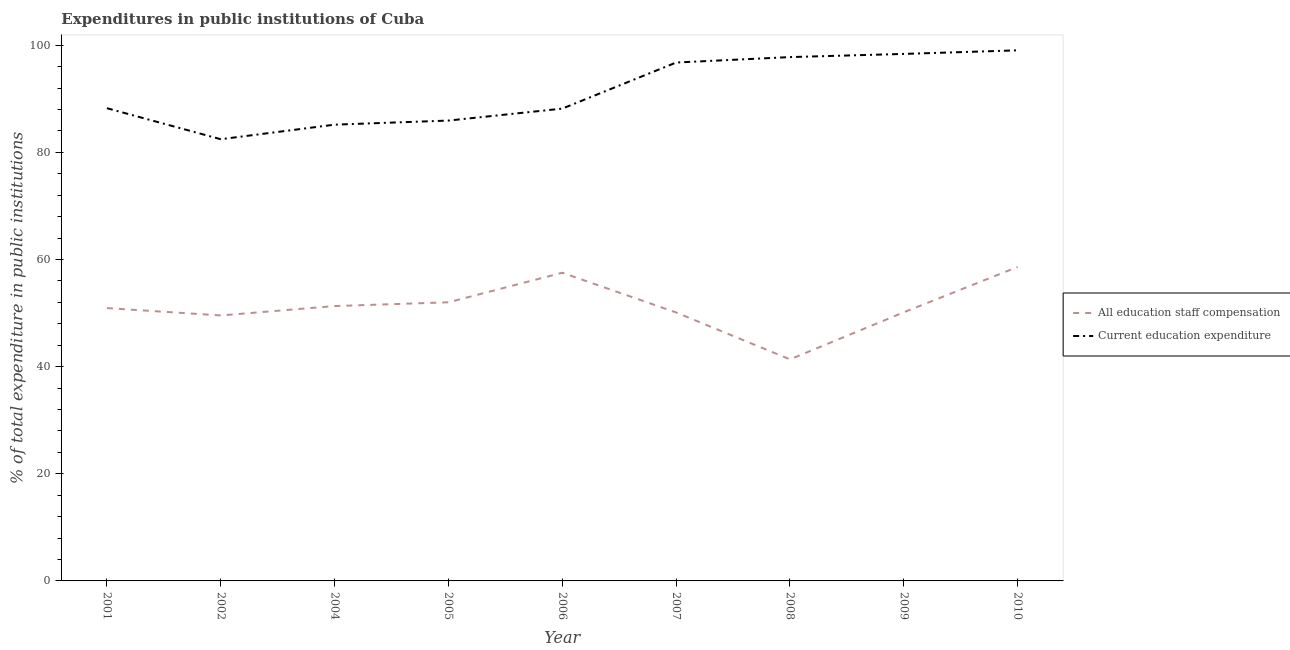Does the line corresponding to expenditure in staff compensation intersect with the line corresponding to expenditure in education?
Give a very brief answer. No. What is the expenditure in staff compensation in 2008?
Provide a short and direct response. 41.36. Across all years, what is the maximum expenditure in education?
Your response must be concise. 99.05. Across all years, what is the minimum expenditure in education?
Make the answer very short. 82.45. In which year was the expenditure in staff compensation maximum?
Ensure brevity in your answer.  2010. What is the total expenditure in education in the graph?
Provide a short and direct response. 821.94. What is the difference between the expenditure in staff compensation in 2007 and that in 2008?
Offer a very short reply. 8.76. What is the difference between the expenditure in staff compensation in 2007 and the expenditure in education in 2006?
Ensure brevity in your answer.  -38.05. What is the average expenditure in education per year?
Provide a short and direct response. 91.33. In the year 2002, what is the difference between the expenditure in staff compensation and expenditure in education?
Offer a terse response. -32.9. What is the ratio of the expenditure in staff compensation in 2001 to that in 2005?
Offer a terse response. 0.98. Is the difference between the expenditure in staff compensation in 2001 and 2010 greater than the difference between the expenditure in education in 2001 and 2010?
Offer a very short reply. Yes. What is the difference between the highest and the second highest expenditure in education?
Your answer should be very brief. 0.67. What is the difference between the highest and the lowest expenditure in education?
Provide a succinct answer. 16.59. In how many years, is the expenditure in staff compensation greater than the average expenditure in staff compensation taken over all years?
Offer a very short reply. 4. Is the sum of the expenditure in staff compensation in 2001 and 2006 greater than the maximum expenditure in education across all years?
Make the answer very short. Yes. Does the expenditure in education monotonically increase over the years?
Your answer should be very brief. No. Is the expenditure in staff compensation strictly greater than the expenditure in education over the years?
Offer a terse response. No. Is the expenditure in staff compensation strictly less than the expenditure in education over the years?
Your answer should be very brief. Yes. How many lines are there?
Provide a short and direct response. 2. Are the values on the major ticks of Y-axis written in scientific E-notation?
Provide a short and direct response. No. Does the graph contain any zero values?
Give a very brief answer. No. Does the graph contain grids?
Your response must be concise. No. Where does the legend appear in the graph?
Offer a very short reply. Center right. How many legend labels are there?
Offer a terse response. 2. What is the title of the graph?
Your answer should be compact. Expenditures in public institutions of Cuba. What is the label or title of the X-axis?
Offer a terse response. Year. What is the label or title of the Y-axis?
Your answer should be compact. % of total expenditure in public institutions. What is the % of total expenditure in public institutions of All education staff compensation in 2001?
Keep it short and to the point. 50.93. What is the % of total expenditure in public institutions in Current education expenditure in 2001?
Make the answer very short. 88.24. What is the % of total expenditure in public institutions in All education staff compensation in 2002?
Your answer should be very brief. 49.56. What is the % of total expenditure in public institutions in Current education expenditure in 2002?
Offer a very short reply. 82.45. What is the % of total expenditure in public institutions of All education staff compensation in 2004?
Provide a succinct answer. 51.31. What is the % of total expenditure in public institutions of Current education expenditure in 2004?
Provide a short and direct response. 85.17. What is the % of total expenditure in public institutions in All education staff compensation in 2005?
Keep it short and to the point. 52.01. What is the % of total expenditure in public institutions of Current education expenditure in 2005?
Your answer should be compact. 85.94. What is the % of total expenditure in public institutions in All education staff compensation in 2006?
Your answer should be very brief. 57.53. What is the % of total expenditure in public institutions of Current education expenditure in 2006?
Your answer should be very brief. 88.17. What is the % of total expenditure in public institutions of All education staff compensation in 2007?
Your answer should be compact. 50.11. What is the % of total expenditure in public institutions of Current education expenditure in 2007?
Ensure brevity in your answer.  96.77. What is the % of total expenditure in public institutions in All education staff compensation in 2008?
Provide a succinct answer. 41.36. What is the % of total expenditure in public institutions in Current education expenditure in 2008?
Your response must be concise. 97.78. What is the % of total expenditure in public institutions of All education staff compensation in 2009?
Offer a very short reply. 50.14. What is the % of total expenditure in public institutions of Current education expenditure in 2009?
Provide a succinct answer. 98.38. What is the % of total expenditure in public institutions of All education staff compensation in 2010?
Your response must be concise. 58.61. What is the % of total expenditure in public institutions of Current education expenditure in 2010?
Offer a terse response. 99.05. Across all years, what is the maximum % of total expenditure in public institutions in All education staff compensation?
Keep it short and to the point. 58.61. Across all years, what is the maximum % of total expenditure in public institutions in Current education expenditure?
Your answer should be compact. 99.05. Across all years, what is the minimum % of total expenditure in public institutions of All education staff compensation?
Make the answer very short. 41.36. Across all years, what is the minimum % of total expenditure in public institutions in Current education expenditure?
Offer a terse response. 82.45. What is the total % of total expenditure in public institutions of All education staff compensation in the graph?
Your answer should be very brief. 461.56. What is the total % of total expenditure in public institutions in Current education expenditure in the graph?
Your answer should be compact. 821.94. What is the difference between the % of total expenditure in public institutions in All education staff compensation in 2001 and that in 2002?
Offer a terse response. 1.37. What is the difference between the % of total expenditure in public institutions of Current education expenditure in 2001 and that in 2002?
Provide a short and direct response. 5.79. What is the difference between the % of total expenditure in public institutions in All education staff compensation in 2001 and that in 2004?
Your response must be concise. -0.38. What is the difference between the % of total expenditure in public institutions of Current education expenditure in 2001 and that in 2004?
Your answer should be compact. 3.07. What is the difference between the % of total expenditure in public institutions of All education staff compensation in 2001 and that in 2005?
Offer a very short reply. -1.08. What is the difference between the % of total expenditure in public institutions in Current education expenditure in 2001 and that in 2005?
Your answer should be compact. 2.31. What is the difference between the % of total expenditure in public institutions in All education staff compensation in 2001 and that in 2006?
Offer a very short reply. -6.6. What is the difference between the % of total expenditure in public institutions of Current education expenditure in 2001 and that in 2006?
Your answer should be very brief. 0.08. What is the difference between the % of total expenditure in public institutions of All education staff compensation in 2001 and that in 2007?
Offer a very short reply. 0.82. What is the difference between the % of total expenditure in public institutions of Current education expenditure in 2001 and that in 2007?
Your answer should be very brief. -8.53. What is the difference between the % of total expenditure in public institutions in All education staff compensation in 2001 and that in 2008?
Keep it short and to the point. 9.57. What is the difference between the % of total expenditure in public institutions in Current education expenditure in 2001 and that in 2008?
Give a very brief answer. -9.54. What is the difference between the % of total expenditure in public institutions of All education staff compensation in 2001 and that in 2009?
Offer a terse response. 0.79. What is the difference between the % of total expenditure in public institutions of Current education expenditure in 2001 and that in 2009?
Your answer should be very brief. -10.13. What is the difference between the % of total expenditure in public institutions of All education staff compensation in 2001 and that in 2010?
Your answer should be compact. -7.68. What is the difference between the % of total expenditure in public institutions in Current education expenditure in 2001 and that in 2010?
Provide a succinct answer. -10.8. What is the difference between the % of total expenditure in public institutions of All education staff compensation in 2002 and that in 2004?
Provide a succinct answer. -1.75. What is the difference between the % of total expenditure in public institutions in Current education expenditure in 2002 and that in 2004?
Your answer should be compact. -2.72. What is the difference between the % of total expenditure in public institutions of All education staff compensation in 2002 and that in 2005?
Give a very brief answer. -2.46. What is the difference between the % of total expenditure in public institutions of Current education expenditure in 2002 and that in 2005?
Give a very brief answer. -3.48. What is the difference between the % of total expenditure in public institutions in All education staff compensation in 2002 and that in 2006?
Offer a very short reply. -7.97. What is the difference between the % of total expenditure in public institutions of Current education expenditure in 2002 and that in 2006?
Make the answer very short. -5.71. What is the difference between the % of total expenditure in public institutions in All education staff compensation in 2002 and that in 2007?
Provide a succinct answer. -0.56. What is the difference between the % of total expenditure in public institutions of Current education expenditure in 2002 and that in 2007?
Your answer should be compact. -14.32. What is the difference between the % of total expenditure in public institutions of All education staff compensation in 2002 and that in 2008?
Offer a very short reply. 8.2. What is the difference between the % of total expenditure in public institutions in Current education expenditure in 2002 and that in 2008?
Offer a very short reply. -15.33. What is the difference between the % of total expenditure in public institutions in All education staff compensation in 2002 and that in 2009?
Make the answer very short. -0.59. What is the difference between the % of total expenditure in public institutions in Current education expenditure in 2002 and that in 2009?
Keep it short and to the point. -15.92. What is the difference between the % of total expenditure in public institutions in All education staff compensation in 2002 and that in 2010?
Your answer should be compact. -9.06. What is the difference between the % of total expenditure in public institutions of Current education expenditure in 2002 and that in 2010?
Keep it short and to the point. -16.59. What is the difference between the % of total expenditure in public institutions in All education staff compensation in 2004 and that in 2005?
Provide a short and direct response. -0.71. What is the difference between the % of total expenditure in public institutions in Current education expenditure in 2004 and that in 2005?
Ensure brevity in your answer.  -0.76. What is the difference between the % of total expenditure in public institutions of All education staff compensation in 2004 and that in 2006?
Offer a very short reply. -6.22. What is the difference between the % of total expenditure in public institutions of Current education expenditure in 2004 and that in 2006?
Your answer should be very brief. -3. What is the difference between the % of total expenditure in public institutions in All education staff compensation in 2004 and that in 2007?
Provide a succinct answer. 1.19. What is the difference between the % of total expenditure in public institutions in Current education expenditure in 2004 and that in 2007?
Offer a very short reply. -11.6. What is the difference between the % of total expenditure in public institutions in All education staff compensation in 2004 and that in 2008?
Your answer should be very brief. 9.95. What is the difference between the % of total expenditure in public institutions of Current education expenditure in 2004 and that in 2008?
Keep it short and to the point. -12.61. What is the difference between the % of total expenditure in public institutions of All education staff compensation in 2004 and that in 2009?
Your response must be concise. 1.16. What is the difference between the % of total expenditure in public institutions in Current education expenditure in 2004 and that in 2009?
Your answer should be very brief. -13.21. What is the difference between the % of total expenditure in public institutions in All education staff compensation in 2004 and that in 2010?
Make the answer very short. -7.31. What is the difference between the % of total expenditure in public institutions of Current education expenditure in 2004 and that in 2010?
Provide a succinct answer. -13.88. What is the difference between the % of total expenditure in public institutions of All education staff compensation in 2005 and that in 2006?
Your answer should be very brief. -5.51. What is the difference between the % of total expenditure in public institutions in Current education expenditure in 2005 and that in 2006?
Provide a succinct answer. -2.23. What is the difference between the % of total expenditure in public institutions of All education staff compensation in 2005 and that in 2007?
Keep it short and to the point. 1.9. What is the difference between the % of total expenditure in public institutions in Current education expenditure in 2005 and that in 2007?
Your response must be concise. -10.83. What is the difference between the % of total expenditure in public institutions in All education staff compensation in 2005 and that in 2008?
Ensure brevity in your answer.  10.66. What is the difference between the % of total expenditure in public institutions of Current education expenditure in 2005 and that in 2008?
Keep it short and to the point. -11.85. What is the difference between the % of total expenditure in public institutions of All education staff compensation in 2005 and that in 2009?
Provide a succinct answer. 1.87. What is the difference between the % of total expenditure in public institutions of Current education expenditure in 2005 and that in 2009?
Offer a terse response. -12.44. What is the difference between the % of total expenditure in public institutions in All education staff compensation in 2005 and that in 2010?
Offer a terse response. -6.6. What is the difference between the % of total expenditure in public institutions in Current education expenditure in 2005 and that in 2010?
Your answer should be compact. -13.11. What is the difference between the % of total expenditure in public institutions of All education staff compensation in 2006 and that in 2007?
Your answer should be compact. 7.41. What is the difference between the % of total expenditure in public institutions in Current education expenditure in 2006 and that in 2007?
Give a very brief answer. -8.6. What is the difference between the % of total expenditure in public institutions in All education staff compensation in 2006 and that in 2008?
Your answer should be very brief. 16.17. What is the difference between the % of total expenditure in public institutions of Current education expenditure in 2006 and that in 2008?
Provide a short and direct response. -9.62. What is the difference between the % of total expenditure in public institutions in All education staff compensation in 2006 and that in 2009?
Offer a very short reply. 7.38. What is the difference between the % of total expenditure in public institutions of Current education expenditure in 2006 and that in 2009?
Provide a succinct answer. -10.21. What is the difference between the % of total expenditure in public institutions in All education staff compensation in 2006 and that in 2010?
Give a very brief answer. -1.09. What is the difference between the % of total expenditure in public institutions of Current education expenditure in 2006 and that in 2010?
Provide a succinct answer. -10.88. What is the difference between the % of total expenditure in public institutions in All education staff compensation in 2007 and that in 2008?
Your answer should be compact. 8.76. What is the difference between the % of total expenditure in public institutions of Current education expenditure in 2007 and that in 2008?
Provide a succinct answer. -1.01. What is the difference between the % of total expenditure in public institutions of All education staff compensation in 2007 and that in 2009?
Give a very brief answer. -0.03. What is the difference between the % of total expenditure in public institutions in Current education expenditure in 2007 and that in 2009?
Give a very brief answer. -1.61. What is the difference between the % of total expenditure in public institutions in All education staff compensation in 2007 and that in 2010?
Provide a short and direct response. -8.5. What is the difference between the % of total expenditure in public institutions in Current education expenditure in 2007 and that in 2010?
Offer a very short reply. -2.28. What is the difference between the % of total expenditure in public institutions of All education staff compensation in 2008 and that in 2009?
Provide a succinct answer. -8.79. What is the difference between the % of total expenditure in public institutions in Current education expenditure in 2008 and that in 2009?
Give a very brief answer. -0.59. What is the difference between the % of total expenditure in public institutions of All education staff compensation in 2008 and that in 2010?
Ensure brevity in your answer.  -17.26. What is the difference between the % of total expenditure in public institutions in Current education expenditure in 2008 and that in 2010?
Keep it short and to the point. -1.26. What is the difference between the % of total expenditure in public institutions in All education staff compensation in 2009 and that in 2010?
Make the answer very short. -8.47. What is the difference between the % of total expenditure in public institutions in Current education expenditure in 2009 and that in 2010?
Provide a short and direct response. -0.67. What is the difference between the % of total expenditure in public institutions in All education staff compensation in 2001 and the % of total expenditure in public institutions in Current education expenditure in 2002?
Make the answer very short. -31.52. What is the difference between the % of total expenditure in public institutions of All education staff compensation in 2001 and the % of total expenditure in public institutions of Current education expenditure in 2004?
Ensure brevity in your answer.  -34.24. What is the difference between the % of total expenditure in public institutions of All education staff compensation in 2001 and the % of total expenditure in public institutions of Current education expenditure in 2005?
Provide a succinct answer. -35.01. What is the difference between the % of total expenditure in public institutions of All education staff compensation in 2001 and the % of total expenditure in public institutions of Current education expenditure in 2006?
Provide a short and direct response. -37.24. What is the difference between the % of total expenditure in public institutions of All education staff compensation in 2001 and the % of total expenditure in public institutions of Current education expenditure in 2007?
Provide a short and direct response. -45.84. What is the difference between the % of total expenditure in public institutions of All education staff compensation in 2001 and the % of total expenditure in public institutions of Current education expenditure in 2008?
Your response must be concise. -46.85. What is the difference between the % of total expenditure in public institutions of All education staff compensation in 2001 and the % of total expenditure in public institutions of Current education expenditure in 2009?
Offer a very short reply. -47.45. What is the difference between the % of total expenditure in public institutions in All education staff compensation in 2001 and the % of total expenditure in public institutions in Current education expenditure in 2010?
Make the answer very short. -48.12. What is the difference between the % of total expenditure in public institutions in All education staff compensation in 2002 and the % of total expenditure in public institutions in Current education expenditure in 2004?
Your answer should be compact. -35.61. What is the difference between the % of total expenditure in public institutions in All education staff compensation in 2002 and the % of total expenditure in public institutions in Current education expenditure in 2005?
Your answer should be very brief. -36.38. What is the difference between the % of total expenditure in public institutions in All education staff compensation in 2002 and the % of total expenditure in public institutions in Current education expenditure in 2006?
Give a very brief answer. -38.61. What is the difference between the % of total expenditure in public institutions of All education staff compensation in 2002 and the % of total expenditure in public institutions of Current education expenditure in 2007?
Provide a short and direct response. -47.21. What is the difference between the % of total expenditure in public institutions in All education staff compensation in 2002 and the % of total expenditure in public institutions in Current education expenditure in 2008?
Make the answer very short. -48.23. What is the difference between the % of total expenditure in public institutions of All education staff compensation in 2002 and the % of total expenditure in public institutions of Current education expenditure in 2009?
Keep it short and to the point. -48.82. What is the difference between the % of total expenditure in public institutions of All education staff compensation in 2002 and the % of total expenditure in public institutions of Current education expenditure in 2010?
Make the answer very short. -49.49. What is the difference between the % of total expenditure in public institutions of All education staff compensation in 2004 and the % of total expenditure in public institutions of Current education expenditure in 2005?
Offer a terse response. -34.63. What is the difference between the % of total expenditure in public institutions of All education staff compensation in 2004 and the % of total expenditure in public institutions of Current education expenditure in 2006?
Offer a very short reply. -36.86. What is the difference between the % of total expenditure in public institutions of All education staff compensation in 2004 and the % of total expenditure in public institutions of Current education expenditure in 2007?
Your answer should be very brief. -45.46. What is the difference between the % of total expenditure in public institutions of All education staff compensation in 2004 and the % of total expenditure in public institutions of Current education expenditure in 2008?
Your response must be concise. -46.48. What is the difference between the % of total expenditure in public institutions of All education staff compensation in 2004 and the % of total expenditure in public institutions of Current education expenditure in 2009?
Make the answer very short. -47.07. What is the difference between the % of total expenditure in public institutions in All education staff compensation in 2004 and the % of total expenditure in public institutions in Current education expenditure in 2010?
Provide a short and direct response. -47.74. What is the difference between the % of total expenditure in public institutions of All education staff compensation in 2005 and the % of total expenditure in public institutions of Current education expenditure in 2006?
Your response must be concise. -36.15. What is the difference between the % of total expenditure in public institutions of All education staff compensation in 2005 and the % of total expenditure in public institutions of Current education expenditure in 2007?
Keep it short and to the point. -44.76. What is the difference between the % of total expenditure in public institutions in All education staff compensation in 2005 and the % of total expenditure in public institutions in Current education expenditure in 2008?
Your answer should be compact. -45.77. What is the difference between the % of total expenditure in public institutions in All education staff compensation in 2005 and the % of total expenditure in public institutions in Current education expenditure in 2009?
Provide a succinct answer. -46.36. What is the difference between the % of total expenditure in public institutions of All education staff compensation in 2005 and the % of total expenditure in public institutions of Current education expenditure in 2010?
Your answer should be very brief. -47.03. What is the difference between the % of total expenditure in public institutions of All education staff compensation in 2006 and the % of total expenditure in public institutions of Current education expenditure in 2007?
Give a very brief answer. -39.24. What is the difference between the % of total expenditure in public institutions in All education staff compensation in 2006 and the % of total expenditure in public institutions in Current education expenditure in 2008?
Provide a succinct answer. -40.26. What is the difference between the % of total expenditure in public institutions of All education staff compensation in 2006 and the % of total expenditure in public institutions of Current education expenditure in 2009?
Provide a short and direct response. -40.85. What is the difference between the % of total expenditure in public institutions of All education staff compensation in 2006 and the % of total expenditure in public institutions of Current education expenditure in 2010?
Offer a very short reply. -41.52. What is the difference between the % of total expenditure in public institutions of All education staff compensation in 2007 and the % of total expenditure in public institutions of Current education expenditure in 2008?
Ensure brevity in your answer.  -47.67. What is the difference between the % of total expenditure in public institutions of All education staff compensation in 2007 and the % of total expenditure in public institutions of Current education expenditure in 2009?
Keep it short and to the point. -48.26. What is the difference between the % of total expenditure in public institutions in All education staff compensation in 2007 and the % of total expenditure in public institutions in Current education expenditure in 2010?
Your answer should be very brief. -48.93. What is the difference between the % of total expenditure in public institutions of All education staff compensation in 2008 and the % of total expenditure in public institutions of Current education expenditure in 2009?
Provide a succinct answer. -57.02. What is the difference between the % of total expenditure in public institutions in All education staff compensation in 2008 and the % of total expenditure in public institutions in Current education expenditure in 2010?
Make the answer very short. -57.69. What is the difference between the % of total expenditure in public institutions in All education staff compensation in 2009 and the % of total expenditure in public institutions in Current education expenditure in 2010?
Give a very brief answer. -48.9. What is the average % of total expenditure in public institutions of All education staff compensation per year?
Offer a very short reply. 51.28. What is the average % of total expenditure in public institutions of Current education expenditure per year?
Your answer should be compact. 91.33. In the year 2001, what is the difference between the % of total expenditure in public institutions of All education staff compensation and % of total expenditure in public institutions of Current education expenditure?
Offer a terse response. -37.31. In the year 2002, what is the difference between the % of total expenditure in public institutions in All education staff compensation and % of total expenditure in public institutions in Current education expenditure?
Your response must be concise. -32.9. In the year 2004, what is the difference between the % of total expenditure in public institutions of All education staff compensation and % of total expenditure in public institutions of Current education expenditure?
Ensure brevity in your answer.  -33.86. In the year 2005, what is the difference between the % of total expenditure in public institutions of All education staff compensation and % of total expenditure in public institutions of Current education expenditure?
Give a very brief answer. -33.92. In the year 2006, what is the difference between the % of total expenditure in public institutions in All education staff compensation and % of total expenditure in public institutions in Current education expenditure?
Provide a short and direct response. -30.64. In the year 2007, what is the difference between the % of total expenditure in public institutions of All education staff compensation and % of total expenditure in public institutions of Current education expenditure?
Ensure brevity in your answer.  -46.66. In the year 2008, what is the difference between the % of total expenditure in public institutions in All education staff compensation and % of total expenditure in public institutions in Current education expenditure?
Keep it short and to the point. -56.43. In the year 2009, what is the difference between the % of total expenditure in public institutions of All education staff compensation and % of total expenditure in public institutions of Current education expenditure?
Ensure brevity in your answer.  -48.23. In the year 2010, what is the difference between the % of total expenditure in public institutions of All education staff compensation and % of total expenditure in public institutions of Current education expenditure?
Make the answer very short. -40.43. What is the ratio of the % of total expenditure in public institutions in All education staff compensation in 2001 to that in 2002?
Your response must be concise. 1.03. What is the ratio of the % of total expenditure in public institutions of Current education expenditure in 2001 to that in 2002?
Your response must be concise. 1.07. What is the ratio of the % of total expenditure in public institutions in All education staff compensation in 2001 to that in 2004?
Provide a short and direct response. 0.99. What is the ratio of the % of total expenditure in public institutions of Current education expenditure in 2001 to that in 2004?
Your response must be concise. 1.04. What is the ratio of the % of total expenditure in public institutions in All education staff compensation in 2001 to that in 2005?
Provide a succinct answer. 0.98. What is the ratio of the % of total expenditure in public institutions of Current education expenditure in 2001 to that in 2005?
Your response must be concise. 1.03. What is the ratio of the % of total expenditure in public institutions in All education staff compensation in 2001 to that in 2006?
Provide a succinct answer. 0.89. What is the ratio of the % of total expenditure in public institutions in All education staff compensation in 2001 to that in 2007?
Keep it short and to the point. 1.02. What is the ratio of the % of total expenditure in public institutions in Current education expenditure in 2001 to that in 2007?
Offer a very short reply. 0.91. What is the ratio of the % of total expenditure in public institutions in All education staff compensation in 2001 to that in 2008?
Make the answer very short. 1.23. What is the ratio of the % of total expenditure in public institutions of Current education expenditure in 2001 to that in 2008?
Your answer should be very brief. 0.9. What is the ratio of the % of total expenditure in public institutions in All education staff compensation in 2001 to that in 2009?
Give a very brief answer. 1.02. What is the ratio of the % of total expenditure in public institutions in Current education expenditure in 2001 to that in 2009?
Give a very brief answer. 0.9. What is the ratio of the % of total expenditure in public institutions in All education staff compensation in 2001 to that in 2010?
Provide a short and direct response. 0.87. What is the ratio of the % of total expenditure in public institutions in Current education expenditure in 2001 to that in 2010?
Your answer should be very brief. 0.89. What is the ratio of the % of total expenditure in public institutions of All education staff compensation in 2002 to that in 2004?
Your response must be concise. 0.97. What is the ratio of the % of total expenditure in public institutions in Current education expenditure in 2002 to that in 2004?
Offer a very short reply. 0.97. What is the ratio of the % of total expenditure in public institutions in All education staff compensation in 2002 to that in 2005?
Keep it short and to the point. 0.95. What is the ratio of the % of total expenditure in public institutions in Current education expenditure in 2002 to that in 2005?
Your response must be concise. 0.96. What is the ratio of the % of total expenditure in public institutions in All education staff compensation in 2002 to that in 2006?
Offer a very short reply. 0.86. What is the ratio of the % of total expenditure in public institutions of Current education expenditure in 2002 to that in 2006?
Make the answer very short. 0.94. What is the ratio of the % of total expenditure in public institutions in All education staff compensation in 2002 to that in 2007?
Ensure brevity in your answer.  0.99. What is the ratio of the % of total expenditure in public institutions in Current education expenditure in 2002 to that in 2007?
Your answer should be compact. 0.85. What is the ratio of the % of total expenditure in public institutions in All education staff compensation in 2002 to that in 2008?
Give a very brief answer. 1.2. What is the ratio of the % of total expenditure in public institutions of Current education expenditure in 2002 to that in 2008?
Your response must be concise. 0.84. What is the ratio of the % of total expenditure in public institutions in All education staff compensation in 2002 to that in 2009?
Keep it short and to the point. 0.99. What is the ratio of the % of total expenditure in public institutions of Current education expenditure in 2002 to that in 2009?
Your response must be concise. 0.84. What is the ratio of the % of total expenditure in public institutions in All education staff compensation in 2002 to that in 2010?
Your answer should be compact. 0.85. What is the ratio of the % of total expenditure in public institutions of Current education expenditure in 2002 to that in 2010?
Your response must be concise. 0.83. What is the ratio of the % of total expenditure in public institutions of All education staff compensation in 2004 to that in 2005?
Ensure brevity in your answer.  0.99. What is the ratio of the % of total expenditure in public institutions of All education staff compensation in 2004 to that in 2006?
Ensure brevity in your answer.  0.89. What is the ratio of the % of total expenditure in public institutions in Current education expenditure in 2004 to that in 2006?
Give a very brief answer. 0.97. What is the ratio of the % of total expenditure in public institutions of All education staff compensation in 2004 to that in 2007?
Your response must be concise. 1.02. What is the ratio of the % of total expenditure in public institutions of Current education expenditure in 2004 to that in 2007?
Give a very brief answer. 0.88. What is the ratio of the % of total expenditure in public institutions of All education staff compensation in 2004 to that in 2008?
Provide a short and direct response. 1.24. What is the ratio of the % of total expenditure in public institutions of Current education expenditure in 2004 to that in 2008?
Offer a terse response. 0.87. What is the ratio of the % of total expenditure in public institutions in All education staff compensation in 2004 to that in 2009?
Keep it short and to the point. 1.02. What is the ratio of the % of total expenditure in public institutions in Current education expenditure in 2004 to that in 2009?
Your response must be concise. 0.87. What is the ratio of the % of total expenditure in public institutions of All education staff compensation in 2004 to that in 2010?
Ensure brevity in your answer.  0.88. What is the ratio of the % of total expenditure in public institutions of Current education expenditure in 2004 to that in 2010?
Provide a succinct answer. 0.86. What is the ratio of the % of total expenditure in public institutions of All education staff compensation in 2005 to that in 2006?
Offer a very short reply. 0.9. What is the ratio of the % of total expenditure in public institutions of Current education expenditure in 2005 to that in 2006?
Offer a very short reply. 0.97. What is the ratio of the % of total expenditure in public institutions in All education staff compensation in 2005 to that in 2007?
Keep it short and to the point. 1.04. What is the ratio of the % of total expenditure in public institutions of Current education expenditure in 2005 to that in 2007?
Keep it short and to the point. 0.89. What is the ratio of the % of total expenditure in public institutions in All education staff compensation in 2005 to that in 2008?
Ensure brevity in your answer.  1.26. What is the ratio of the % of total expenditure in public institutions of Current education expenditure in 2005 to that in 2008?
Keep it short and to the point. 0.88. What is the ratio of the % of total expenditure in public institutions of All education staff compensation in 2005 to that in 2009?
Ensure brevity in your answer.  1.04. What is the ratio of the % of total expenditure in public institutions of Current education expenditure in 2005 to that in 2009?
Offer a terse response. 0.87. What is the ratio of the % of total expenditure in public institutions of All education staff compensation in 2005 to that in 2010?
Your response must be concise. 0.89. What is the ratio of the % of total expenditure in public institutions in Current education expenditure in 2005 to that in 2010?
Provide a succinct answer. 0.87. What is the ratio of the % of total expenditure in public institutions in All education staff compensation in 2006 to that in 2007?
Provide a short and direct response. 1.15. What is the ratio of the % of total expenditure in public institutions of Current education expenditure in 2006 to that in 2007?
Your response must be concise. 0.91. What is the ratio of the % of total expenditure in public institutions of All education staff compensation in 2006 to that in 2008?
Offer a terse response. 1.39. What is the ratio of the % of total expenditure in public institutions of Current education expenditure in 2006 to that in 2008?
Provide a short and direct response. 0.9. What is the ratio of the % of total expenditure in public institutions of All education staff compensation in 2006 to that in 2009?
Give a very brief answer. 1.15. What is the ratio of the % of total expenditure in public institutions of Current education expenditure in 2006 to that in 2009?
Give a very brief answer. 0.9. What is the ratio of the % of total expenditure in public institutions of All education staff compensation in 2006 to that in 2010?
Give a very brief answer. 0.98. What is the ratio of the % of total expenditure in public institutions of Current education expenditure in 2006 to that in 2010?
Your response must be concise. 0.89. What is the ratio of the % of total expenditure in public institutions of All education staff compensation in 2007 to that in 2008?
Your response must be concise. 1.21. What is the ratio of the % of total expenditure in public institutions of Current education expenditure in 2007 to that in 2009?
Your answer should be compact. 0.98. What is the ratio of the % of total expenditure in public institutions in All education staff compensation in 2007 to that in 2010?
Your answer should be compact. 0.85. What is the ratio of the % of total expenditure in public institutions of Current education expenditure in 2007 to that in 2010?
Your answer should be very brief. 0.98. What is the ratio of the % of total expenditure in public institutions of All education staff compensation in 2008 to that in 2009?
Provide a short and direct response. 0.82. What is the ratio of the % of total expenditure in public institutions of Current education expenditure in 2008 to that in 2009?
Make the answer very short. 0.99. What is the ratio of the % of total expenditure in public institutions of All education staff compensation in 2008 to that in 2010?
Ensure brevity in your answer.  0.71. What is the ratio of the % of total expenditure in public institutions of Current education expenditure in 2008 to that in 2010?
Your response must be concise. 0.99. What is the ratio of the % of total expenditure in public institutions in All education staff compensation in 2009 to that in 2010?
Your response must be concise. 0.86. What is the ratio of the % of total expenditure in public institutions in Current education expenditure in 2009 to that in 2010?
Your response must be concise. 0.99. What is the difference between the highest and the second highest % of total expenditure in public institutions of All education staff compensation?
Ensure brevity in your answer.  1.09. What is the difference between the highest and the second highest % of total expenditure in public institutions in Current education expenditure?
Your answer should be compact. 0.67. What is the difference between the highest and the lowest % of total expenditure in public institutions in All education staff compensation?
Give a very brief answer. 17.26. What is the difference between the highest and the lowest % of total expenditure in public institutions of Current education expenditure?
Provide a short and direct response. 16.59. 